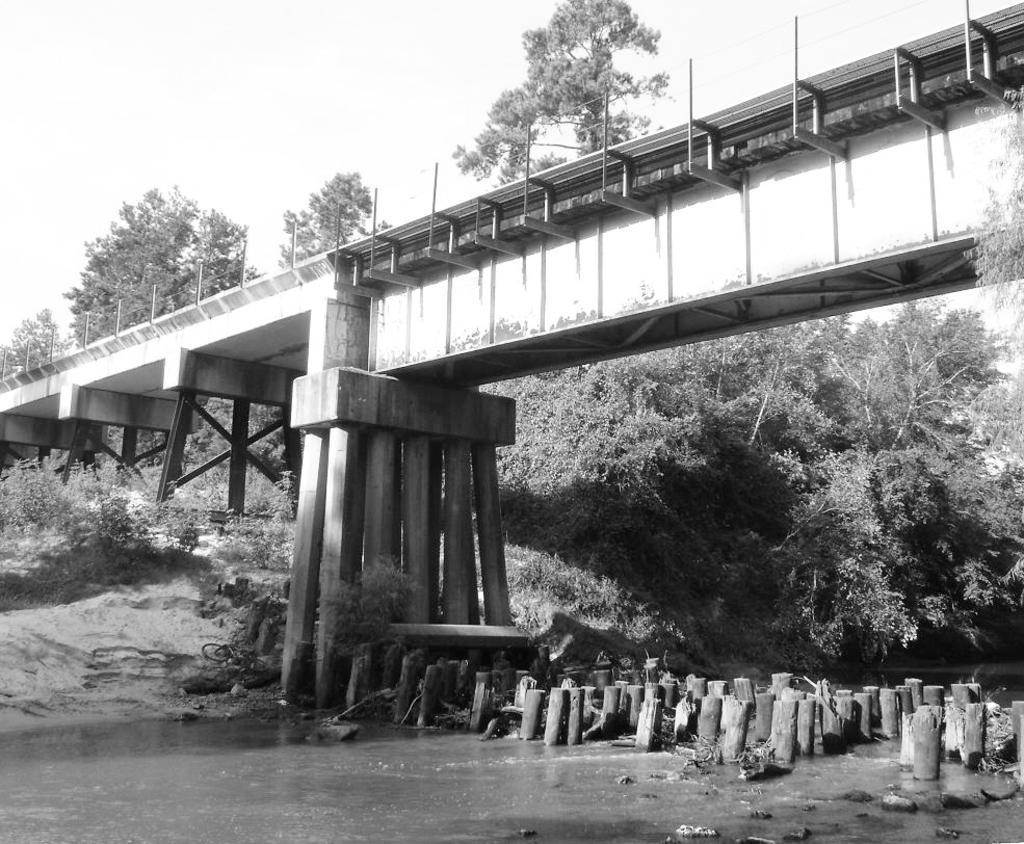What is the color scheme of the image? The image is black and white. What structure can be seen in the image? There is a bridge in the image. What are the small poles in the image used for? The purpose of the small poles in the image is not specified, but they could be used for support or decoration. What is visible on the ground in the image? The ground is visible in the image, and plants and trees are present. What is visible in the background of the image? The sky is visible in the background of the image. What type of ring can be seen on the manager's finger in the image? There is no manager or ring present in the image. What type of magic is being performed on the bridge in the image? There is no magic or performance taking place in the image; it is a static scene of a bridge and its surroundings. 